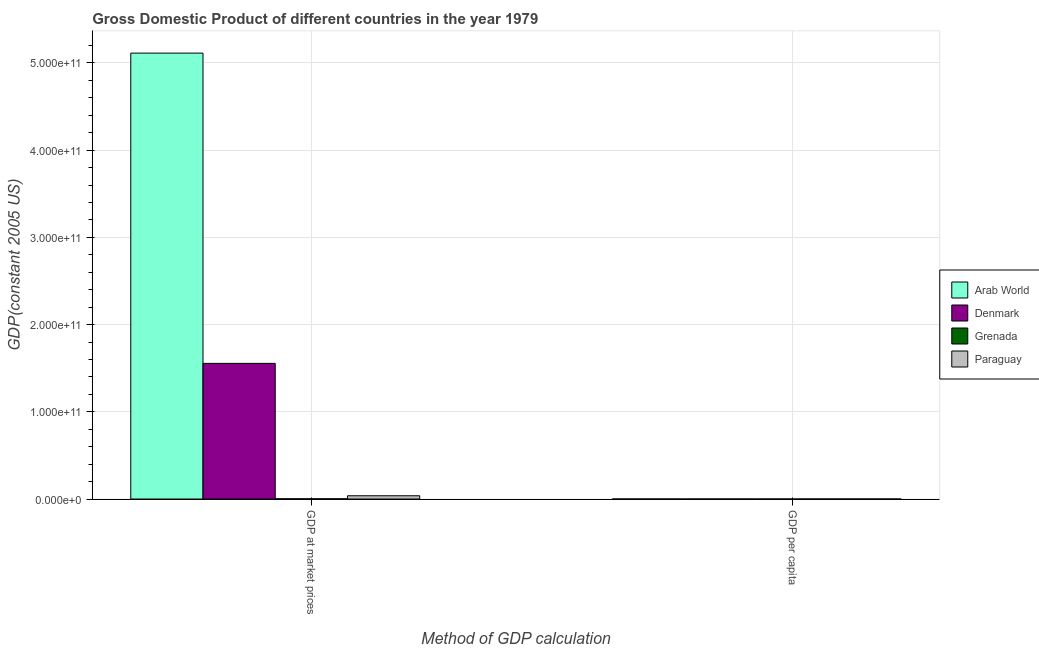How many different coloured bars are there?
Ensure brevity in your answer.  4. How many groups of bars are there?
Provide a short and direct response. 2. Are the number of bars per tick equal to the number of legend labels?
Give a very brief answer. Yes. How many bars are there on the 1st tick from the left?
Your answer should be compact. 4. How many bars are there on the 1st tick from the right?
Offer a very short reply. 4. What is the label of the 2nd group of bars from the left?
Make the answer very short. GDP per capita. What is the gdp per capita in Arab World?
Your response must be concise. 3208.01. Across all countries, what is the maximum gdp per capita?
Your answer should be very brief. 3.04e+04. Across all countries, what is the minimum gdp per capita?
Provide a succinct answer. 1213.17. In which country was the gdp at market prices maximum?
Your answer should be very brief. Arab World. In which country was the gdp at market prices minimum?
Provide a succinct answer. Grenada. What is the total gdp per capita in the graph?
Your response must be concise. 3.75e+04. What is the difference between the gdp at market prices in Arab World and that in Grenada?
Offer a terse response. 5.11e+11. What is the difference between the gdp per capita in Arab World and the gdp at market prices in Paraguay?
Your response must be concise. -3.75e+09. What is the average gdp at market prices per country?
Ensure brevity in your answer.  1.68e+11. What is the difference between the gdp per capita and gdp at market prices in Grenada?
Give a very brief answer. -2.40e+08. What is the ratio of the gdp at market prices in Paraguay to that in Denmark?
Offer a very short reply. 0.02. In how many countries, is the gdp at market prices greater than the average gdp at market prices taken over all countries?
Your answer should be very brief. 1. What does the 3rd bar from the left in GDP per capita represents?
Your answer should be compact. Grenada. What does the 2nd bar from the right in GDP at market prices represents?
Provide a succinct answer. Grenada. How many bars are there?
Give a very brief answer. 8. What is the difference between two consecutive major ticks on the Y-axis?
Offer a very short reply. 1.00e+11. Are the values on the major ticks of Y-axis written in scientific E-notation?
Your answer should be very brief. Yes. Does the graph contain any zero values?
Keep it short and to the point. No. Does the graph contain grids?
Make the answer very short. Yes. Where does the legend appear in the graph?
Give a very brief answer. Center right. How many legend labels are there?
Your answer should be very brief. 4. What is the title of the graph?
Provide a short and direct response. Gross Domestic Product of different countries in the year 1979. What is the label or title of the X-axis?
Provide a short and direct response. Method of GDP calculation. What is the label or title of the Y-axis?
Provide a short and direct response. GDP(constant 2005 US). What is the GDP(constant 2005 US) in Arab World in GDP at market prices?
Your answer should be very brief. 5.11e+11. What is the GDP(constant 2005 US) in Denmark in GDP at market prices?
Your answer should be compact. 1.55e+11. What is the GDP(constant 2005 US) of Grenada in GDP at market prices?
Your answer should be compact. 2.40e+08. What is the GDP(constant 2005 US) in Paraguay in GDP at market prices?
Give a very brief answer. 3.75e+09. What is the GDP(constant 2005 US) in Arab World in GDP per capita?
Provide a short and direct response. 3208.01. What is the GDP(constant 2005 US) in Denmark in GDP per capita?
Keep it short and to the point. 3.04e+04. What is the GDP(constant 2005 US) of Grenada in GDP per capita?
Your response must be concise. 2711.25. What is the GDP(constant 2005 US) in Paraguay in GDP per capita?
Your answer should be very brief. 1213.17. Across all Method of GDP calculation, what is the maximum GDP(constant 2005 US) in Arab World?
Offer a terse response. 5.11e+11. Across all Method of GDP calculation, what is the maximum GDP(constant 2005 US) in Denmark?
Make the answer very short. 1.55e+11. Across all Method of GDP calculation, what is the maximum GDP(constant 2005 US) of Grenada?
Offer a terse response. 2.40e+08. Across all Method of GDP calculation, what is the maximum GDP(constant 2005 US) of Paraguay?
Provide a succinct answer. 3.75e+09. Across all Method of GDP calculation, what is the minimum GDP(constant 2005 US) of Arab World?
Your response must be concise. 3208.01. Across all Method of GDP calculation, what is the minimum GDP(constant 2005 US) of Denmark?
Ensure brevity in your answer.  3.04e+04. Across all Method of GDP calculation, what is the minimum GDP(constant 2005 US) in Grenada?
Ensure brevity in your answer.  2711.25. Across all Method of GDP calculation, what is the minimum GDP(constant 2005 US) in Paraguay?
Your response must be concise. 1213.17. What is the total GDP(constant 2005 US) in Arab World in the graph?
Provide a succinct answer. 5.11e+11. What is the total GDP(constant 2005 US) of Denmark in the graph?
Offer a very short reply. 1.55e+11. What is the total GDP(constant 2005 US) in Grenada in the graph?
Your answer should be compact. 2.40e+08. What is the total GDP(constant 2005 US) of Paraguay in the graph?
Offer a very short reply. 3.75e+09. What is the difference between the GDP(constant 2005 US) of Arab World in GDP at market prices and that in GDP per capita?
Provide a short and direct response. 5.11e+11. What is the difference between the GDP(constant 2005 US) in Denmark in GDP at market prices and that in GDP per capita?
Your answer should be very brief. 1.55e+11. What is the difference between the GDP(constant 2005 US) in Grenada in GDP at market prices and that in GDP per capita?
Your answer should be very brief. 2.40e+08. What is the difference between the GDP(constant 2005 US) in Paraguay in GDP at market prices and that in GDP per capita?
Keep it short and to the point. 3.75e+09. What is the difference between the GDP(constant 2005 US) in Arab World in GDP at market prices and the GDP(constant 2005 US) in Denmark in GDP per capita?
Keep it short and to the point. 5.11e+11. What is the difference between the GDP(constant 2005 US) of Arab World in GDP at market prices and the GDP(constant 2005 US) of Grenada in GDP per capita?
Offer a terse response. 5.11e+11. What is the difference between the GDP(constant 2005 US) of Arab World in GDP at market prices and the GDP(constant 2005 US) of Paraguay in GDP per capita?
Ensure brevity in your answer.  5.11e+11. What is the difference between the GDP(constant 2005 US) in Denmark in GDP at market prices and the GDP(constant 2005 US) in Grenada in GDP per capita?
Your answer should be compact. 1.55e+11. What is the difference between the GDP(constant 2005 US) of Denmark in GDP at market prices and the GDP(constant 2005 US) of Paraguay in GDP per capita?
Your answer should be very brief. 1.55e+11. What is the difference between the GDP(constant 2005 US) in Grenada in GDP at market prices and the GDP(constant 2005 US) in Paraguay in GDP per capita?
Offer a terse response. 2.40e+08. What is the average GDP(constant 2005 US) of Arab World per Method of GDP calculation?
Provide a short and direct response. 2.56e+11. What is the average GDP(constant 2005 US) of Denmark per Method of GDP calculation?
Ensure brevity in your answer.  7.77e+1. What is the average GDP(constant 2005 US) in Grenada per Method of GDP calculation?
Provide a short and direct response. 1.20e+08. What is the average GDP(constant 2005 US) in Paraguay per Method of GDP calculation?
Give a very brief answer. 1.88e+09. What is the difference between the GDP(constant 2005 US) of Arab World and GDP(constant 2005 US) of Denmark in GDP at market prices?
Offer a terse response. 3.56e+11. What is the difference between the GDP(constant 2005 US) of Arab World and GDP(constant 2005 US) of Grenada in GDP at market prices?
Offer a terse response. 5.11e+11. What is the difference between the GDP(constant 2005 US) of Arab World and GDP(constant 2005 US) of Paraguay in GDP at market prices?
Give a very brief answer. 5.07e+11. What is the difference between the GDP(constant 2005 US) of Denmark and GDP(constant 2005 US) of Grenada in GDP at market prices?
Give a very brief answer. 1.55e+11. What is the difference between the GDP(constant 2005 US) in Denmark and GDP(constant 2005 US) in Paraguay in GDP at market prices?
Your answer should be very brief. 1.52e+11. What is the difference between the GDP(constant 2005 US) in Grenada and GDP(constant 2005 US) in Paraguay in GDP at market prices?
Offer a terse response. -3.51e+09. What is the difference between the GDP(constant 2005 US) of Arab World and GDP(constant 2005 US) of Denmark in GDP per capita?
Ensure brevity in your answer.  -2.72e+04. What is the difference between the GDP(constant 2005 US) of Arab World and GDP(constant 2005 US) of Grenada in GDP per capita?
Give a very brief answer. 496.76. What is the difference between the GDP(constant 2005 US) in Arab World and GDP(constant 2005 US) in Paraguay in GDP per capita?
Offer a very short reply. 1994.84. What is the difference between the GDP(constant 2005 US) in Denmark and GDP(constant 2005 US) in Grenada in GDP per capita?
Ensure brevity in your answer.  2.77e+04. What is the difference between the GDP(constant 2005 US) in Denmark and GDP(constant 2005 US) in Paraguay in GDP per capita?
Keep it short and to the point. 2.92e+04. What is the difference between the GDP(constant 2005 US) in Grenada and GDP(constant 2005 US) in Paraguay in GDP per capita?
Offer a terse response. 1498.08. What is the ratio of the GDP(constant 2005 US) in Arab World in GDP at market prices to that in GDP per capita?
Keep it short and to the point. 1.59e+08. What is the ratio of the GDP(constant 2005 US) in Denmark in GDP at market prices to that in GDP per capita?
Make the answer very short. 5.12e+06. What is the ratio of the GDP(constant 2005 US) of Grenada in GDP at market prices to that in GDP per capita?
Your answer should be compact. 8.86e+04. What is the ratio of the GDP(constant 2005 US) in Paraguay in GDP at market prices to that in GDP per capita?
Your response must be concise. 3.09e+06. What is the difference between the highest and the second highest GDP(constant 2005 US) of Arab World?
Offer a terse response. 5.11e+11. What is the difference between the highest and the second highest GDP(constant 2005 US) of Denmark?
Offer a very short reply. 1.55e+11. What is the difference between the highest and the second highest GDP(constant 2005 US) in Grenada?
Offer a very short reply. 2.40e+08. What is the difference between the highest and the second highest GDP(constant 2005 US) of Paraguay?
Provide a succinct answer. 3.75e+09. What is the difference between the highest and the lowest GDP(constant 2005 US) in Arab World?
Ensure brevity in your answer.  5.11e+11. What is the difference between the highest and the lowest GDP(constant 2005 US) of Denmark?
Make the answer very short. 1.55e+11. What is the difference between the highest and the lowest GDP(constant 2005 US) of Grenada?
Offer a terse response. 2.40e+08. What is the difference between the highest and the lowest GDP(constant 2005 US) of Paraguay?
Make the answer very short. 3.75e+09. 